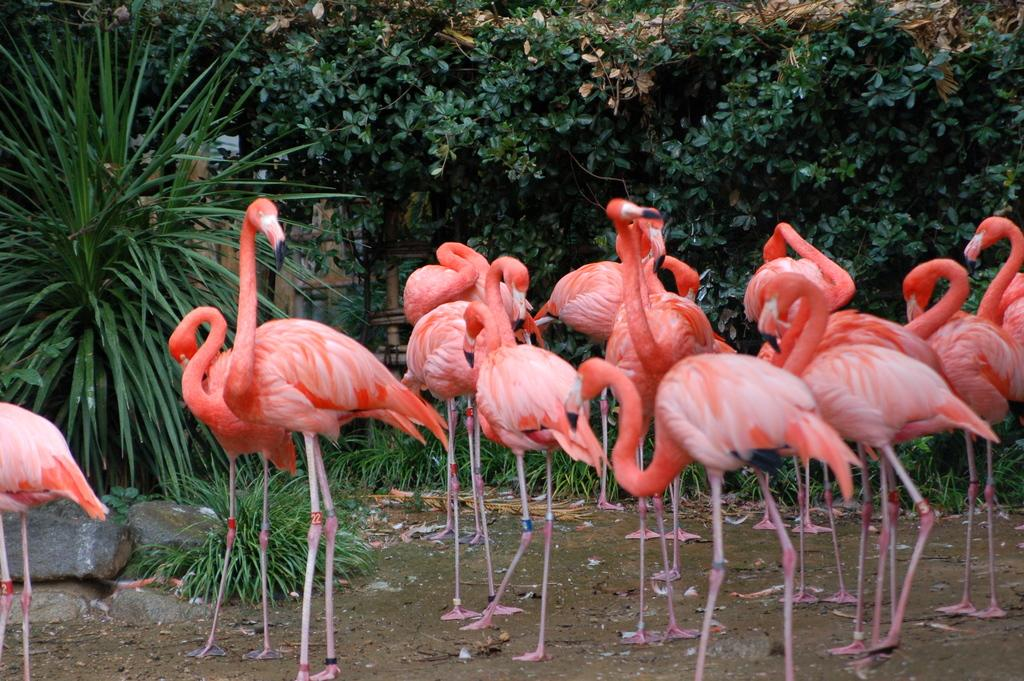What type of animals can be seen in the image? There are birds standing in the image. What type of vegetation is visible in the image? There are trees visible in the image. What type of structure can be seen in the image? There is a building in the image. What type of terrain is present in the image? There is mud visible in the image. What type of material is present in the image? There are stones in the image. What type of development is taking place in the image? There is no development project visible in the image; it primarily features birds, trees, a building, mud, and stones. Can you hear the birds talking to each other in the image? The image is a still picture and does not contain any sounds, so it is not possible to hear the birds talking. 